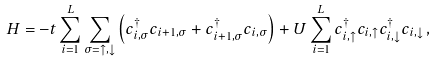Convert formula to latex. <formula><loc_0><loc_0><loc_500><loc_500>H = - t \sum _ { i = 1 } ^ { L } \sum _ { \sigma = \uparrow , \downarrow } \left ( c _ { i , \sigma } ^ { \dagger } c _ { i + 1 , \sigma } + c _ { i + 1 , \sigma } ^ { \dagger } c _ { i , \sigma } \right ) + U \sum _ { i = 1 } ^ { L } c _ { i , \uparrow } ^ { \dagger } c _ { i , \uparrow } c _ { i , \downarrow } ^ { \dagger } c _ { i , \downarrow } \, ,</formula> 